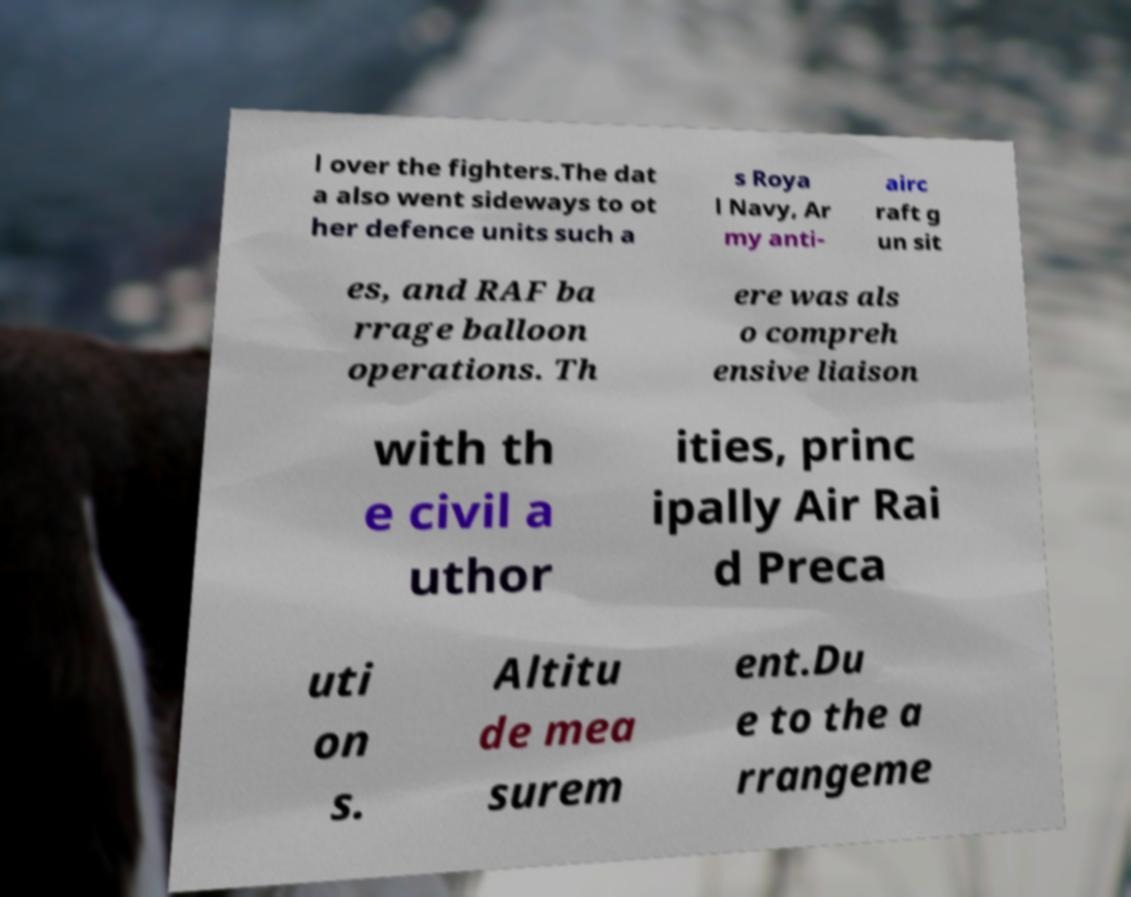Can you accurately transcribe the text from the provided image for me? l over the fighters.The dat a also went sideways to ot her defence units such a s Roya l Navy, Ar my anti- airc raft g un sit es, and RAF ba rrage balloon operations. Th ere was als o compreh ensive liaison with th e civil a uthor ities, princ ipally Air Rai d Preca uti on s. Altitu de mea surem ent.Du e to the a rrangeme 